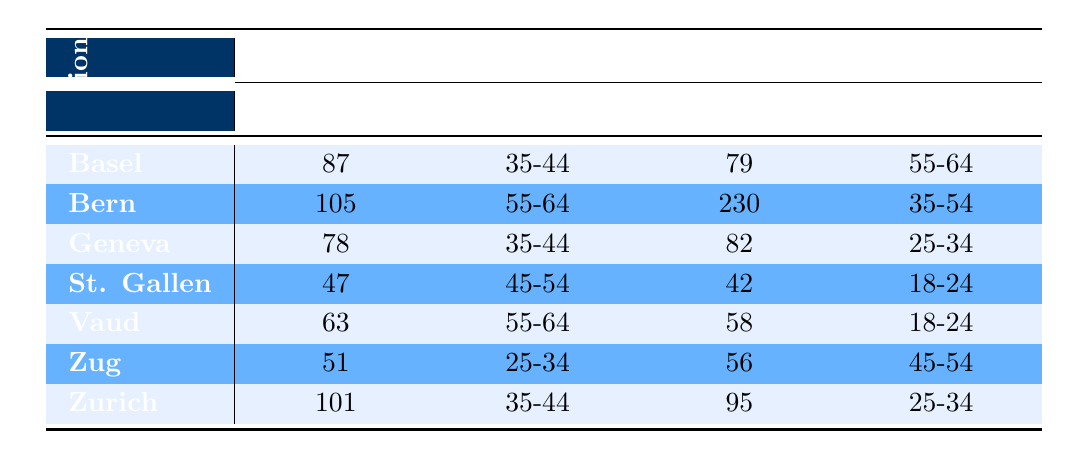What is the total number of female members in the Basel region? The table shows that there are 87 female members in the Basel age group 35-44 and 79 in the Basel age group 55-64. To find the total, we add these two values: 87 + 79 = 166.
Answer: 166 How many male members are there in the St. Gallen region? According to the table, there are 42 male members in the age group 18-24 and 56 in the age group 45-54 for the St. Gallen region. So, to find the total male members, we add: 42 + 47 = 89.
Answer: 89 Which region has the highest number of male members and what is that number? In the table, the Bern region has 230 male members in the age group 35-54, which is more than any other region. Thus, Bern has the highest total male members.
Answer: 230 Are there more female members in the Geneva region than the Zurich region? The table indicates that the Geneva region has 78 female members and the Zurich region has 101 female members. Since 78 is less than 101, the statement is false.
Answer: No What is the average number of male members across all regions? First, identify all male member counts: 82 (Geneva, age 25-34), 230 (Bern, age 35-54), 95 (Zurich, age 25-34), 42 (St. Gallen, age 18-24), 56 (Zug, age 45-54). Adding them gives 82 + 230 + 95 + 42 + 56 = 505. There are 5 entries, so the average is 505 / 5 = 101.
Answer: 101 How many members are there in the Lausanne Olympique Curling club in total? From the table, the Lausanne Olympique Curling club shows 63 female members in the age group 55-64 and 58 male members in the age group 18-24. Adding those gives 63 + 58 = 121 members in total for the club.
Answer: 121 Which gender group has a higher average membership age in the Vaud region? The Vaud region shows 63 female members aged 55-64 and 58 male members aged 18-24. To find the average age, for females, it can be approximated as 55 (midpoint of 55-64), and for males, it is around 21 (midpoint of 18-24). The average membership age is higher for females than for males, making this statement true.
Answer: Yes What percentage of the total membership in the Geneva region is female? The Geneva region shows 78 female members in the age group 35-44 and 82 male members in the age group 25-34, yielding a total of 78 + 82 = 160 members. The percentage of female members is (78 / 160) * 100 = 48.75%.
Answer: 48.75% 